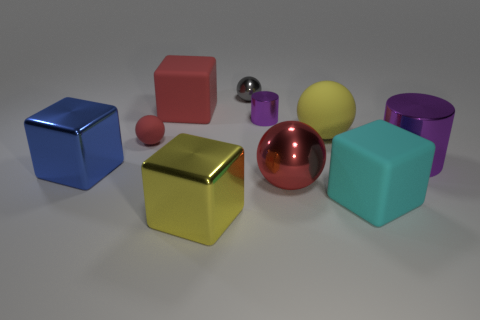Subtract 1 cubes. How many cubes are left? 3 Subtract all blue cylinders. Subtract all blue blocks. How many cylinders are left? 2 Subtract all cubes. How many objects are left? 6 Add 6 blue metal cubes. How many blue metal cubes are left? 7 Add 1 big yellow matte spheres. How many big yellow matte spheres exist? 2 Subtract 1 gray balls. How many objects are left? 9 Subtract all red rubber cubes. Subtract all cyan cubes. How many objects are left? 8 